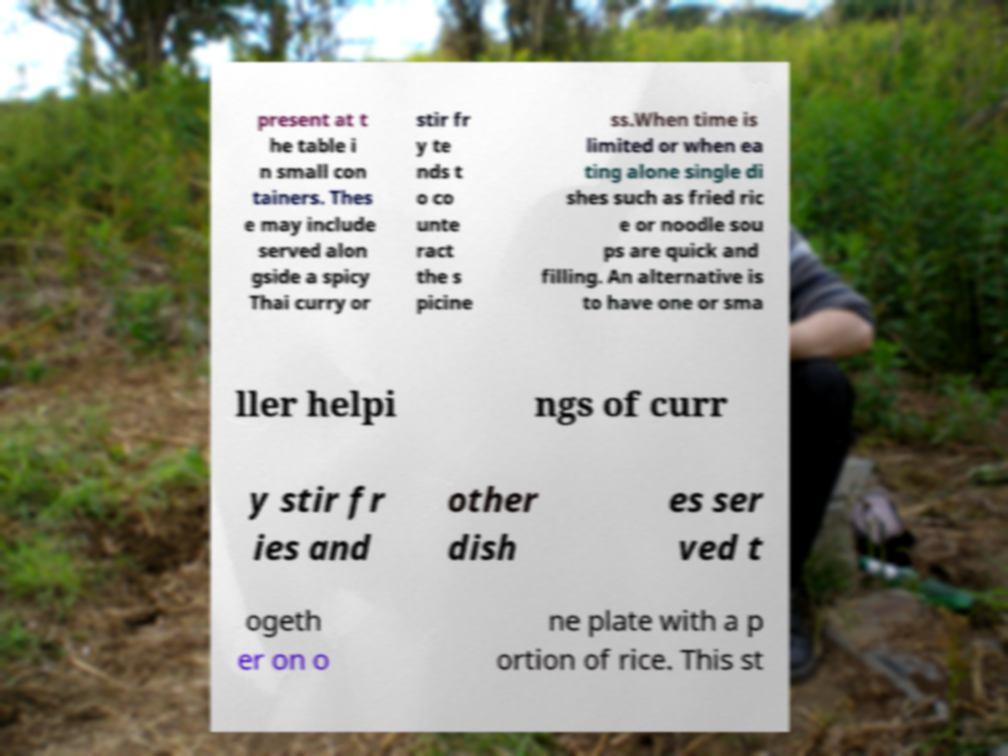I need the written content from this picture converted into text. Can you do that? present at t he table i n small con tainers. Thes e may include served alon gside a spicy Thai curry or stir fr y te nds t o co unte ract the s picine ss.When time is limited or when ea ting alone single di shes such as fried ric e or noodle sou ps are quick and filling. An alternative is to have one or sma ller helpi ngs of curr y stir fr ies and other dish es ser ved t ogeth er on o ne plate with a p ortion of rice. This st 